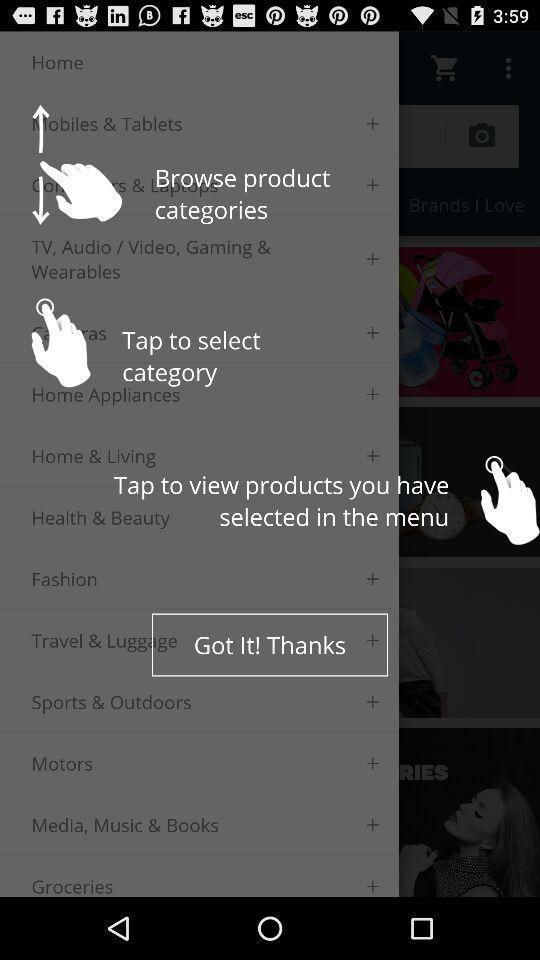Describe the content in this image. Screen shows multiple instructions to browse shopping app. 